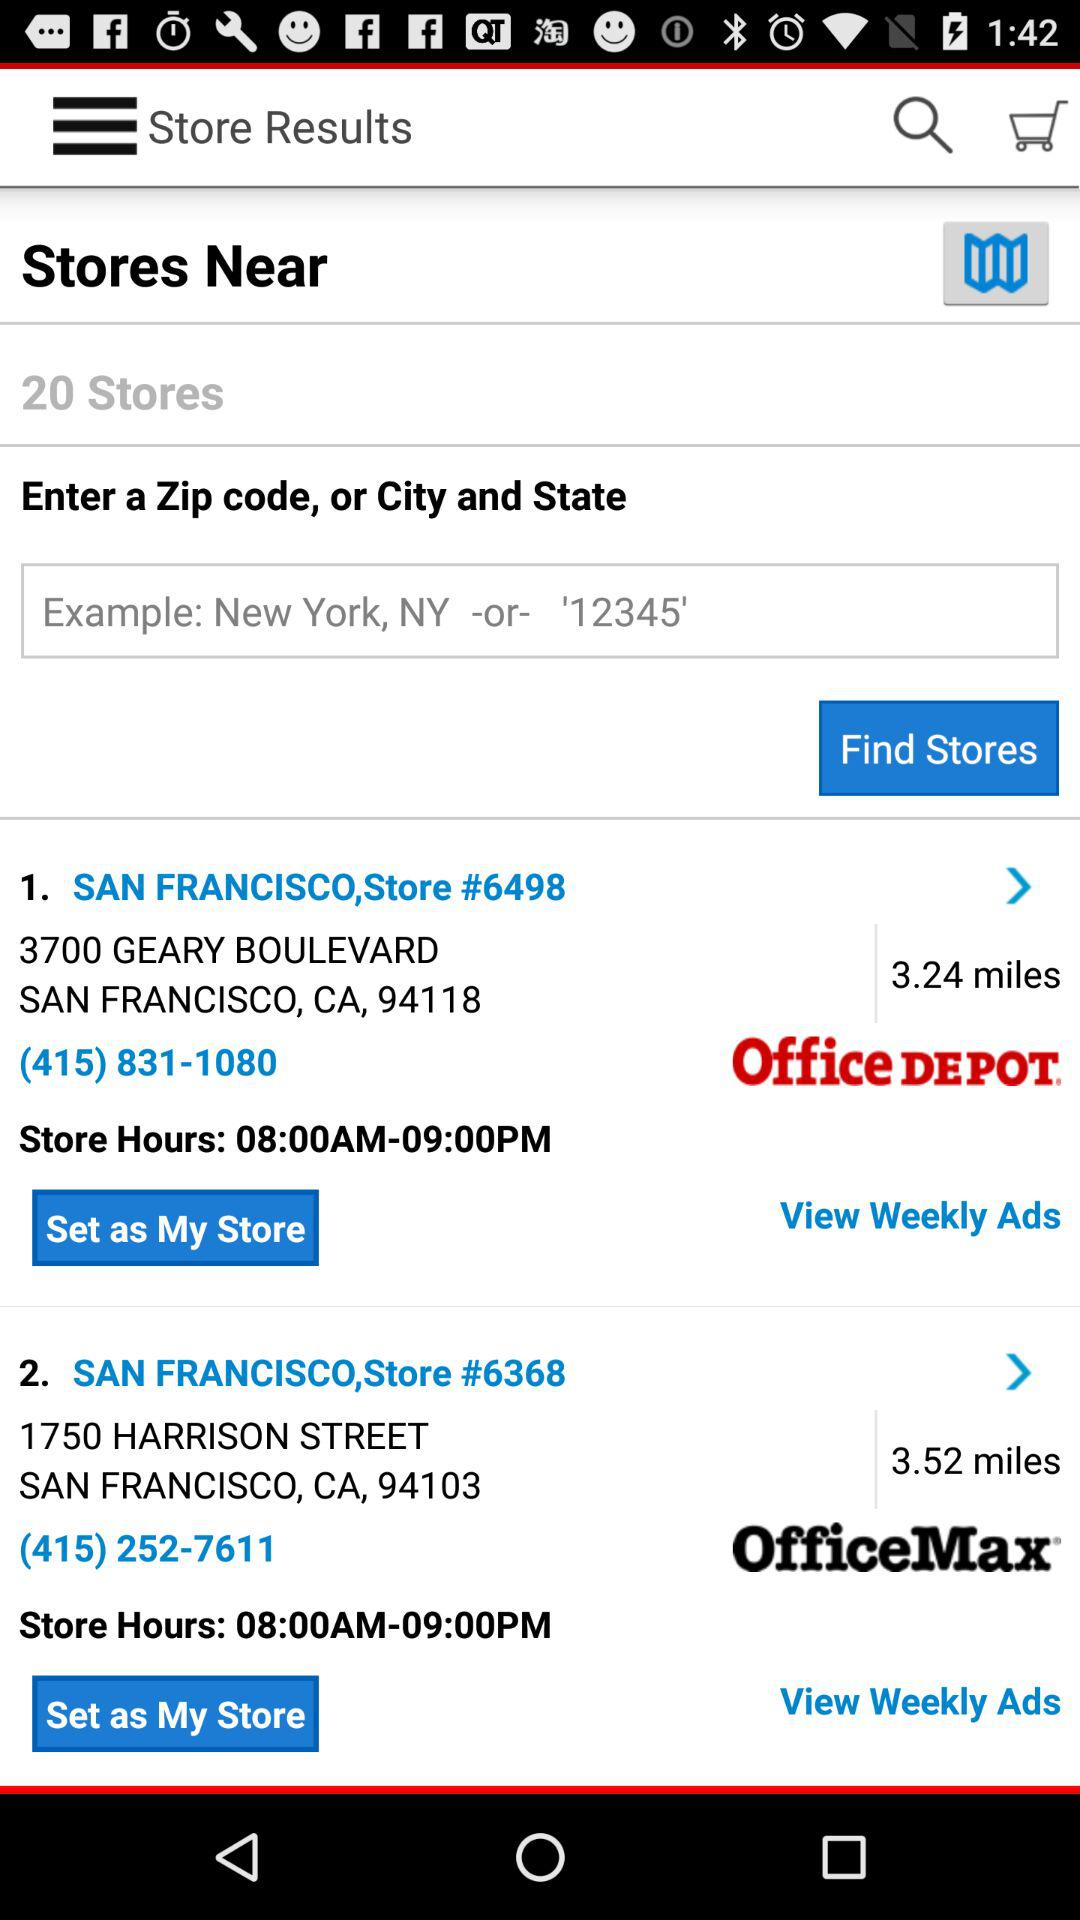What is the location of San Francisco, store number 6368? The location of San Francisco, store number 6368 is 1750 Harrison Street, San Francisco, CA, 94103. 